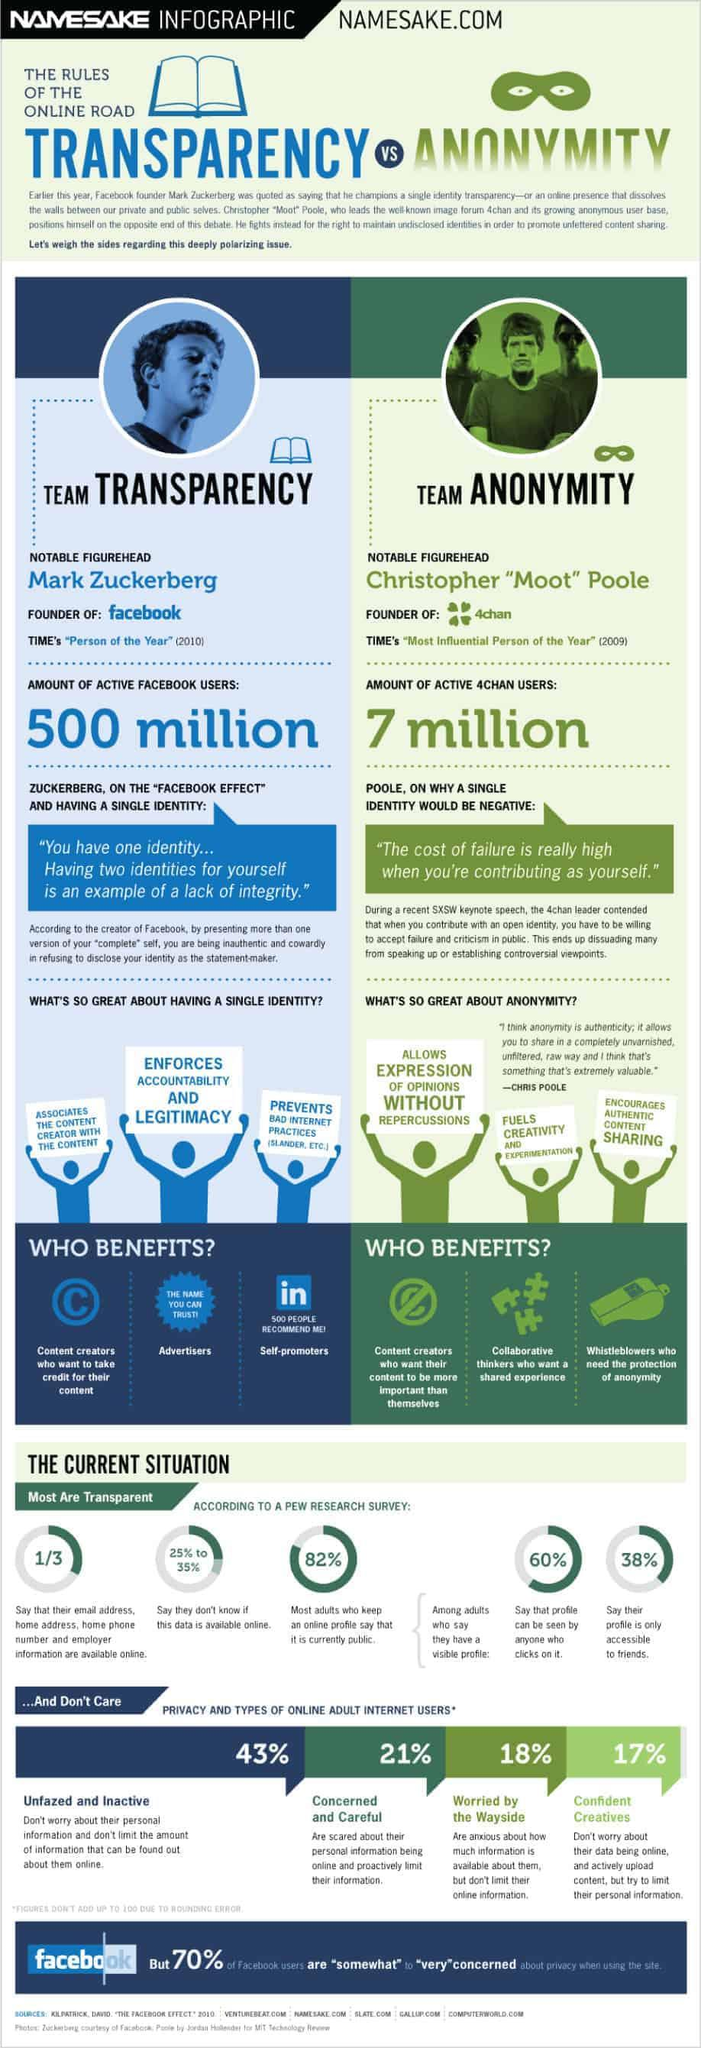Give some essential details in this illustration. According to the given information, approximately 18% of adults do not have a public profile. Transparency and a single identity benefit content creators, advertisers, and self-promoters, according to Zuckerberg. Christopher "Moot" Pole and Mark Zuckerberg are two prominent individuals who are recognized for their contributions and achievements in their respective fields. Second in terms of privacy and usage are internet users who are concerned and careful. 